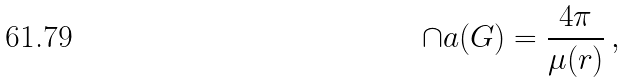<formula> <loc_0><loc_0><loc_500><loc_500>\cap a ( G ) = \frac { 4 \pi } { \mu ( r ) } \, ,</formula> 